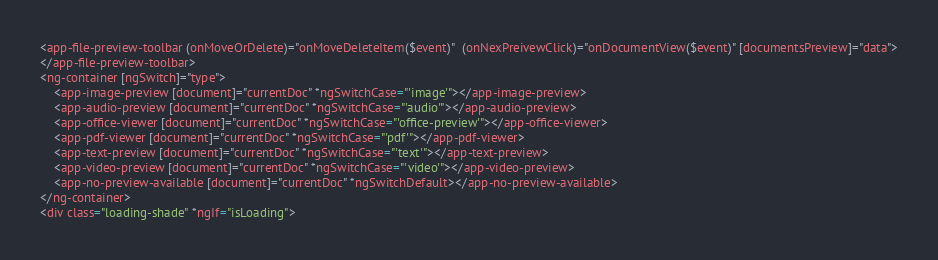<code> <loc_0><loc_0><loc_500><loc_500><_HTML_><app-file-preview-toolbar (onMoveOrDelete)="onMoveDeleteItem($event)"  (onNexPreivewClick)="onDocumentView($event)" [documentsPreview]="data">
</app-file-preview-toolbar>
<ng-container [ngSwitch]="type">
    <app-image-preview [document]="currentDoc" *ngSwitchCase="'image'"></app-image-preview>
    <app-audio-preview [document]="currentDoc" *ngSwitchCase="'audio'"></app-audio-preview>
    <app-office-viewer [document]="currentDoc" *ngSwitchCase="'office-preview'"></app-office-viewer>
    <app-pdf-viewer [document]="currentDoc" *ngSwitchCase="'pdf'"></app-pdf-viewer>
    <app-text-preview [document]="currentDoc" *ngSwitchCase="'text'"></app-text-preview>
    <app-video-preview [document]="currentDoc" *ngSwitchCase="'video'"></app-video-preview>
    <app-no-preview-available [document]="currentDoc" *ngSwitchDefault></app-no-preview-available>
</ng-container>
<div class="loading-shade" *ngIf="isLoading"></code> 